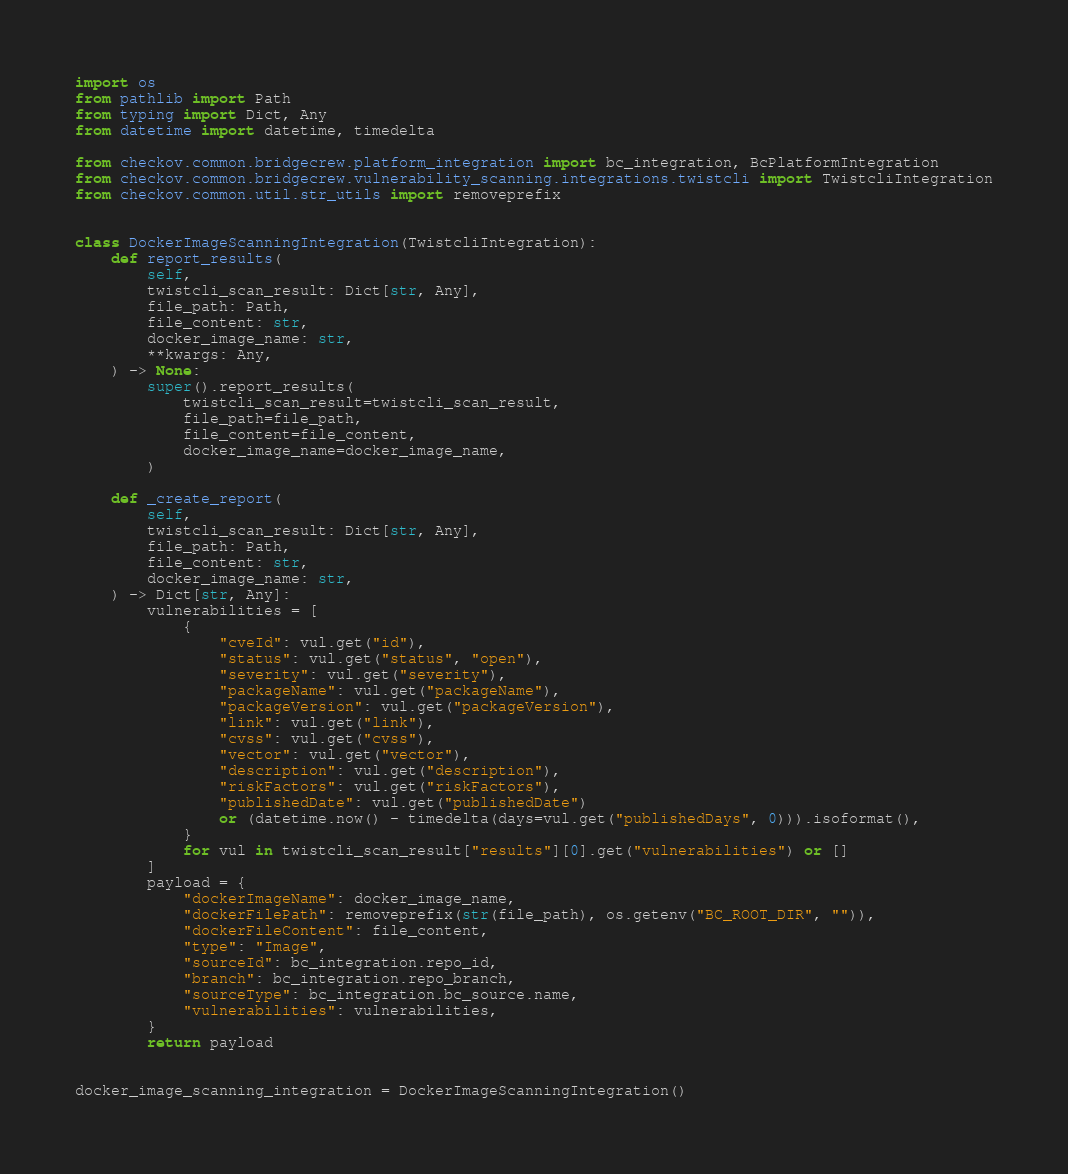Convert code to text. <code><loc_0><loc_0><loc_500><loc_500><_Python_>import os
from pathlib import Path
from typing import Dict, Any
from datetime import datetime, timedelta

from checkov.common.bridgecrew.platform_integration import bc_integration, BcPlatformIntegration
from checkov.common.bridgecrew.vulnerability_scanning.integrations.twistcli import TwistcliIntegration
from checkov.common.util.str_utils import removeprefix


class DockerImageScanningIntegration(TwistcliIntegration):
    def report_results(
        self,
        twistcli_scan_result: Dict[str, Any],
        file_path: Path,
        file_content: str,
        docker_image_name: str,
        **kwargs: Any,
    ) -> None:
        super().report_results(
            twistcli_scan_result=twistcli_scan_result,
            file_path=file_path,
            file_content=file_content,
            docker_image_name=docker_image_name,
        )

    def _create_report(
        self,
        twistcli_scan_result: Dict[str, Any],
        file_path: Path,
        file_content: str,
        docker_image_name: str,
    ) -> Dict[str, Any]:
        vulnerabilities = [
            {
                "cveId": vul.get("id"),
                "status": vul.get("status", "open"),
                "severity": vul.get("severity"),
                "packageName": vul.get("packageName"),
                "packageVersion": vul.get("packageVersion"),
                "link": vul.get("link"),
                "cvss": vul.get("cvss"),
                "vector": vul.get("vector"),
                "description": vul.get("description"),
                "riskFactors": vul.get("riskFactors"),
                "publishedDate": vul.get("publishedDate")
                or (datetime.now() - timedelta(days=vul.get("publishedDays", 0))).isoformat(),
            }
            for vul in twistcli_scan_result["results"][0].get("vulnerabilities") or []
        ]
        payload = {
            "dockerImageName": docker_image_name,
            "dockerFilePath": removeprefix(str(file_path), os.getenv("BC_ROOT_DIR", "")),
            "dockerFileContent": file_content,
            "type": "Image",
            "sourceId": bc_integration.repo_id,
            "branch": bc_integration.repo_branch,
            "sourceType": bc_integration.bc_source.name,
            "vulnerabilities": vulnerabilities,
        }
        return payload


docker_image_scanning_integration = DockerImageScanningIntegration()
</code> 